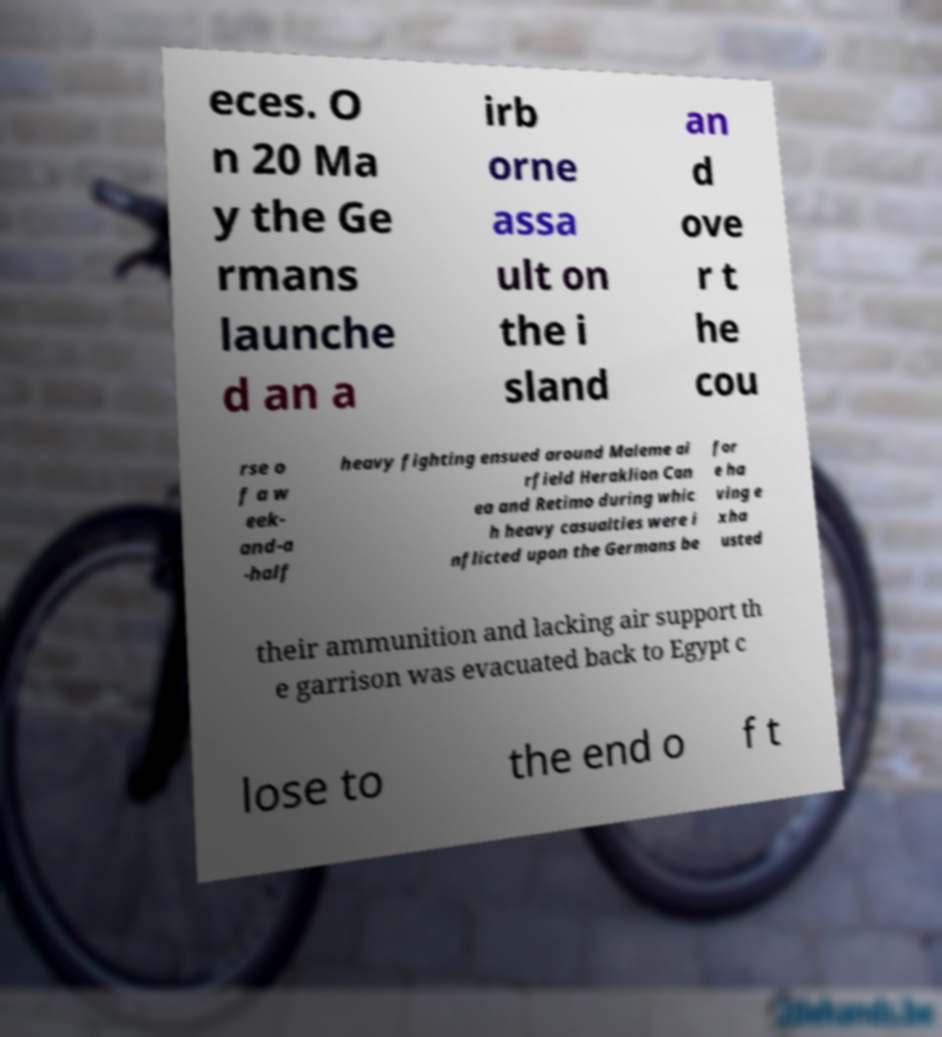Could you assist in decoding the text presented in this image and type it out clearly? eces. O n 20 Ma y the Ge rmans launche d an a irb orne assa ult on the i sland an d ove r t he cou rse o f a w eek- and-a -half heavy fighting ensued around Maleme ai rfield Heraklion Can ea and Retimo during whic h heavy casualties were i nflicted upon the Germans be for e ha ving e xha usted their ammunition and lacking air support th e garrison was evacuated back to Egypt c lose to the end o f t 